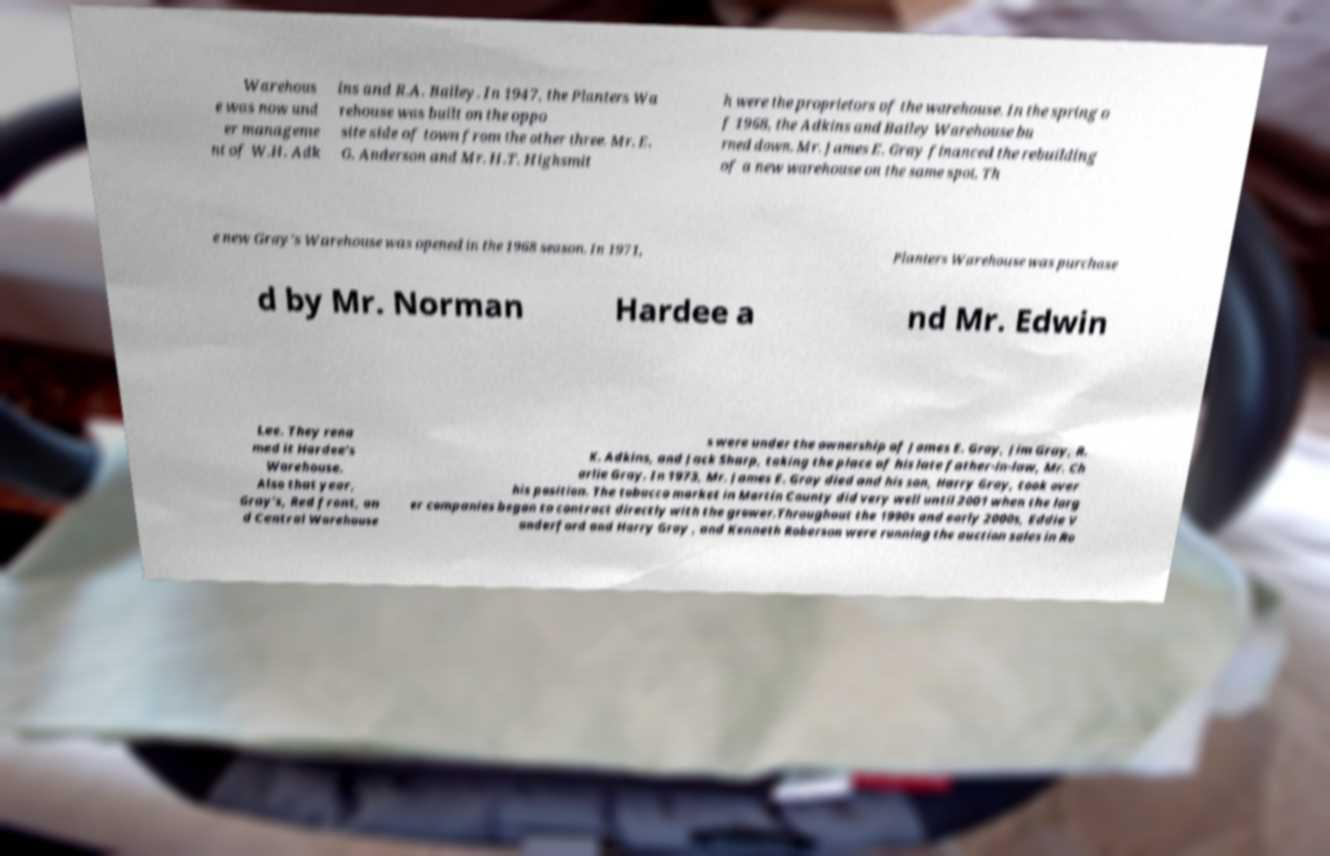Could you extract and type out the text from this image? Warehous e was now und er manageme nt of W.H. Adk ins and R.A. Bailey. In 1947, the Planters Wa rehouse was built on the oppo site side of town from the other three. Mr. E. G. Anderson and Mr. H.T. Highsmit h were the proprietors of the warehouse. In the spring o f 1968, the Adkins and Bailey Warehouse bu rned down. Mr. James E. Gray financed the rebuilding of a new warehouse on the same spot. Th e new Gray's Warehouse was opened in the 1968 season. In 1971, Planters Warehouse was purchase d by Mr. Norman Hardee a nd Mr. Edwin Lee. They rena med it Hardee's Warehouse. Also that year, Gray's, Red front, an d Central Warehouse s were under the ownership of James E. Gray, Jim Gray, R. K. Adkins, and Jack Sharp, taking the place of his late father-in-law, Mr. Ch arlie Gray. In 1973, Mr. James E. Gray died and his son, Harry Gray, took over his position. The tobacco market in Martin County did very well until 2001 when the larg er companies began to contract directly with the grower.Throughout the 1990s and early 2000s, Eddie V anderford and Harry Gray , and Kenneth Roberson were running the auction sales in Ro 